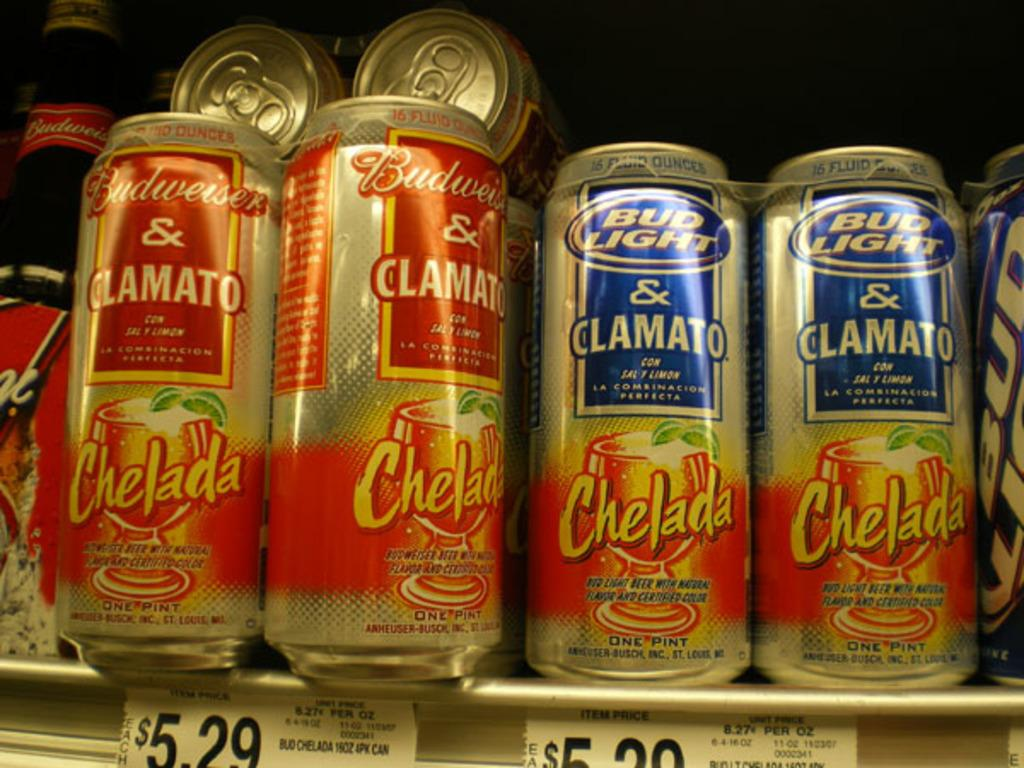<image>
Share a concise interpretation of the image provided. Cans of Bud light and Budweiser with Spanish writing on them sit on a shelf. 